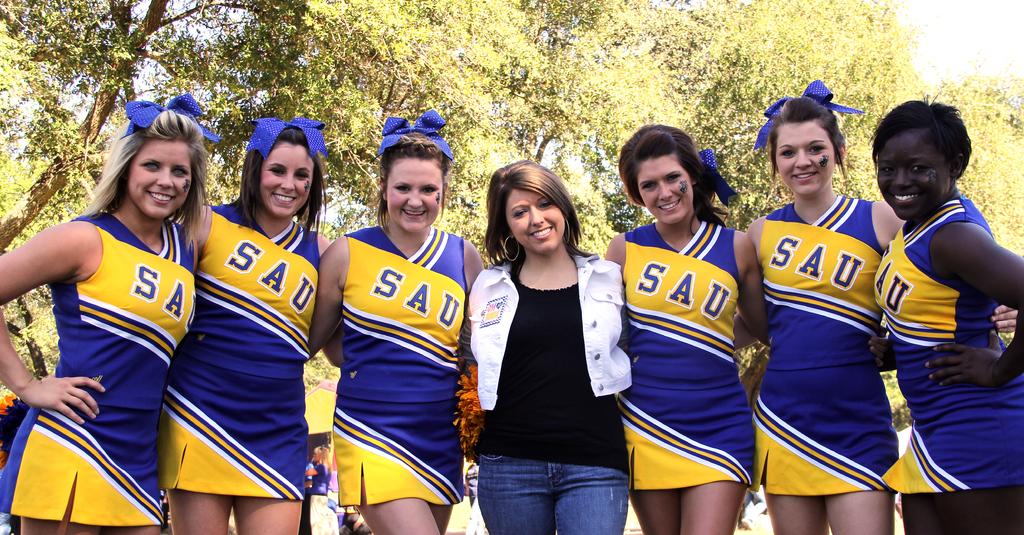What is the teams initials?
Your answer should be compact. Sau. 